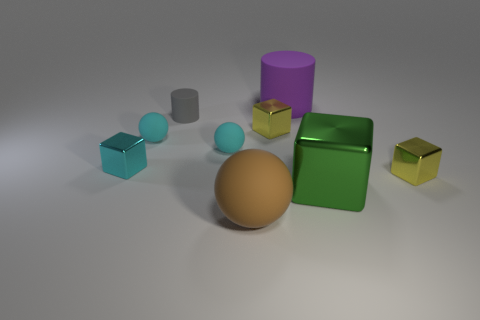There is a metal block that is the same size as the purple cylinder; what is its color? The metal block that matches the size of the purple cylinder is green, displaying a shiny, reflective surface that stands out among the other objects. 